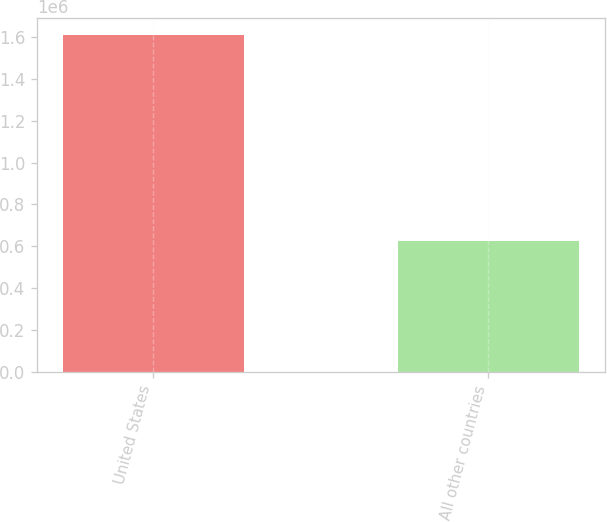Convert chart to OTSL. <chart><loc_0><loc_0><loc_500><loc_500><bar_chart><fcel>United States<fcel>All other countries<nl><fcel>1.61002e+06<fcel>627568<nl></chart> 